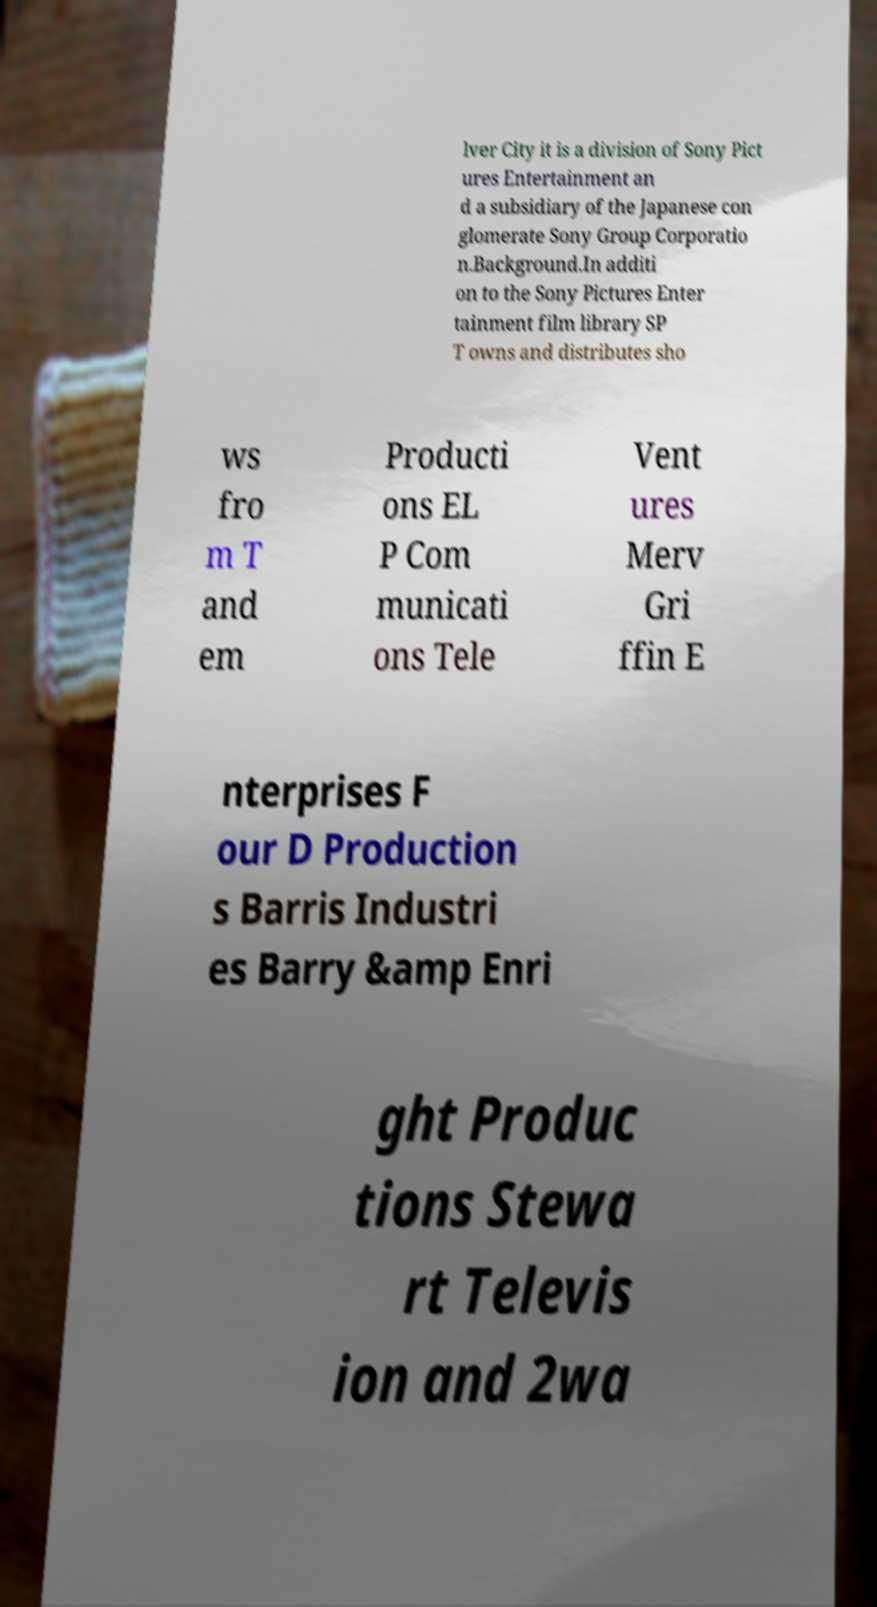Can you read and provide the text displayed in the image?This photo seems to have some interesting text. Can you extract and type it out for me? lver City it is a division of Sony Pict ures Entertainment an d a subsidiary of the Japanese con glomerate Sony Group Corporatio n.Background.In additi on to the Sony Pictures Enter tainment film library SP T owns and distributes sho ws fro m T and em Producti ons EL P Com municati ons Tele Vent ures Merv Gri ffin E nterprises F our D Production s Barris Industri es Barry &amp Enri ght Produc tions Stewa rt Televis ion and 2wa 